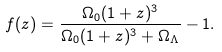<formula> <loc_0><loc_0><loc_500><loc_500>f ( z ) = \frac { \Omega _ { 0 } ( 1 + z ) ^ { 3 } } { \Omega _ { 0 } ( 1 + z ) ^ { 3 } + \Omega _ { \Lambda } } - 1 .</formula> 